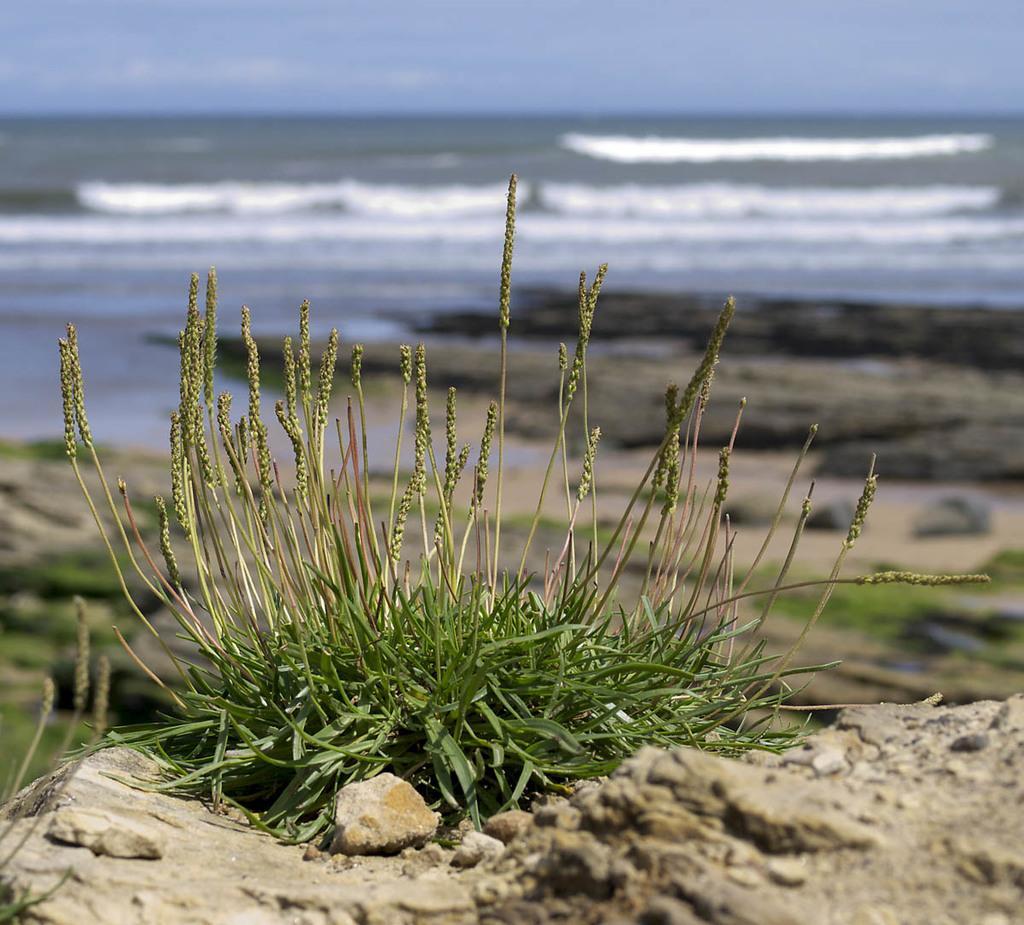In one or two sentences, can you explain what this image depicts? In this image I can see grass and in the background I can see water. I can also see this image is little bit blurry from background. 